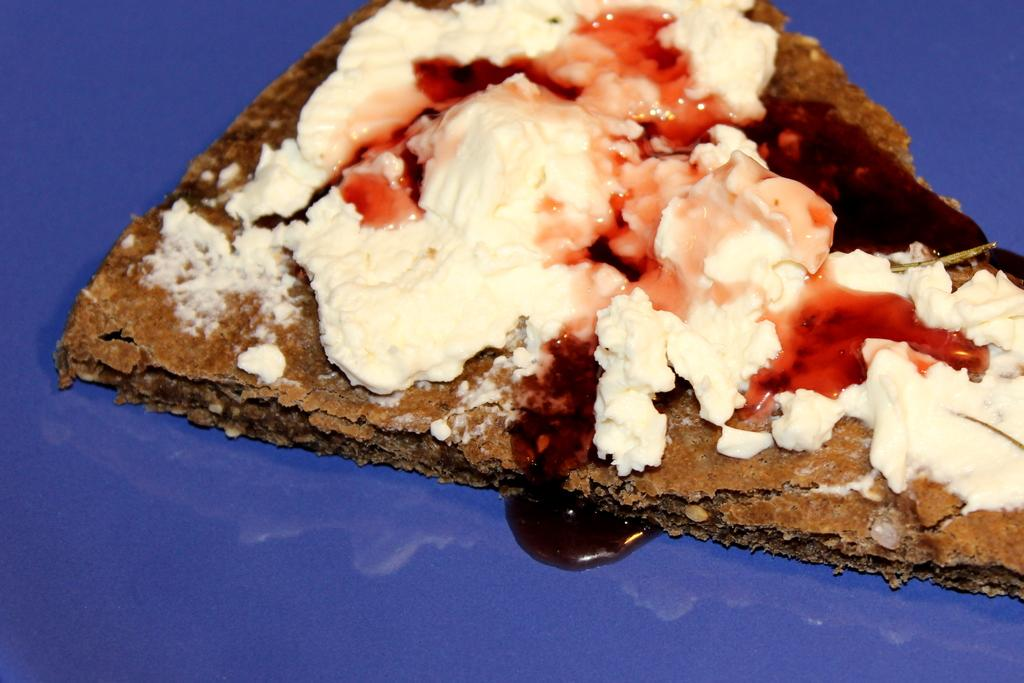What is on the plate in the image? There is food on a plate in the image. How many birds are in the flock that is flying over the food in the image? There is no flock of birds or any other animals present in the image; it only shows food on a plate. 